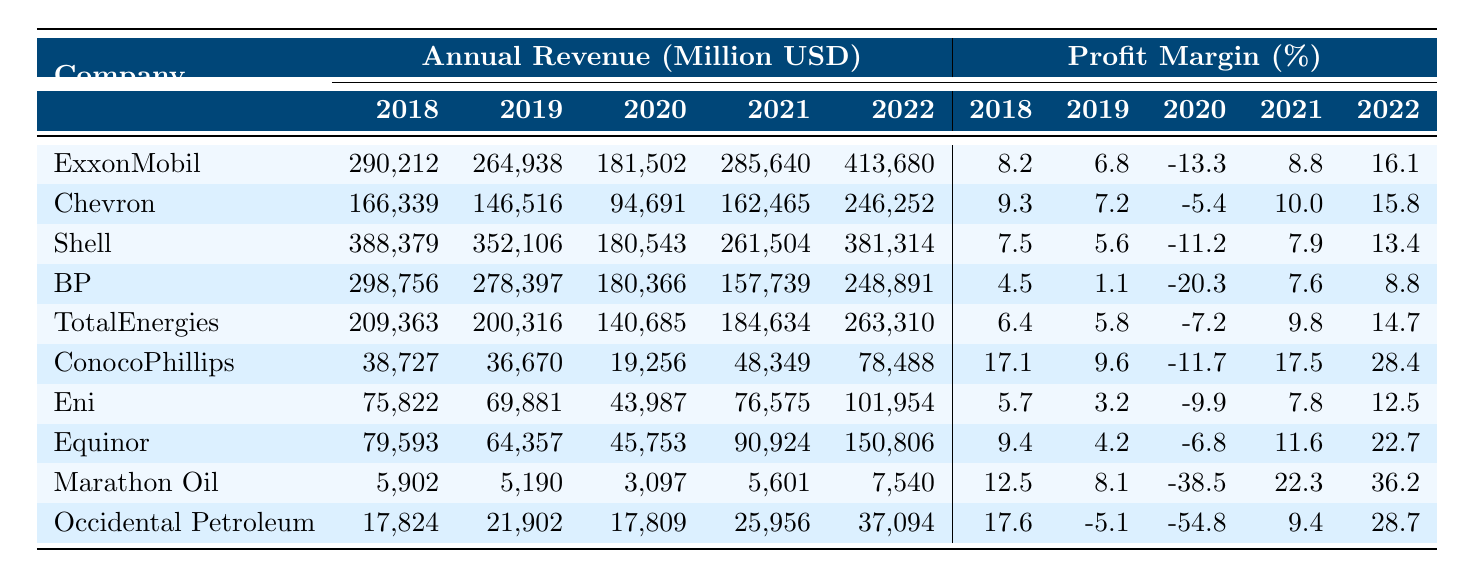What was ExxonMobil's revenue in 2021? The table shows that ExxonMobil's revenue in 2021 is listed as 285,640 million USD.
Answer: 285,640 million USD Which company had the highest profit margin in 2022? In 2022, ConocoPhillips had the highest profit margin at 28.4%.
Answer: ConocoPhillips What is the total revenue of Chevron from 2018 to 2022? To find Chevron's total revenue, sum the revenue for each year: 166,339 + 146,516 + 94,691 + 162,465 + 246,252 = 816,263 million USD.
Answer: 816,263 million USD Did BP's profit margin improve from 2020 to 2021? BP's profit margin went from -20.3% in 2020 to 7.6% in 2021, indicating an improvement.
Answer: Yes Which company's revenue in 2022 was closest to 300,000 million USD? Comparing all companies' 2022 revenues, BP is closest with 248,891 million USD.
Answer: BP What is the average profit margin for TotalEnergies over the years 2018 to 2022? Add TotalEnergies' profit margins for each year: 6.4 + 5.8 - 7.2 + 9.8 + 14.7 = 29.5. Divide by 5: 29.5 / 5 = 5.9%.
Answer: 5.9% Which company showed the largest revenue decline from 2019 to 2020? For each company, calculate the decline: Chevron (146,516 - 94,691 = 51,825), Shell (352,106 - 180,543 = 171,563), BP (278,397 - 180,366 = 98,031), etc. Shell had the largest decline of 171,563 million USD.
Answer: Shell What year did ConocoPhillips experience the lowest revenue? ConocoPhillips' lowest revenue was in 2020, with 19,256 million USD.
Answer: 2020 Was there a year when Occidental Petroleum had a profit margin below 0%? Yes, in 2020, Occidental Petroleum's profit margin was -54.8%.
Answer: Yes Which company had the highest revenue in 2018? In 2018, Shell had the highest revenue at 388,379 million USD.
Answer: Shell 